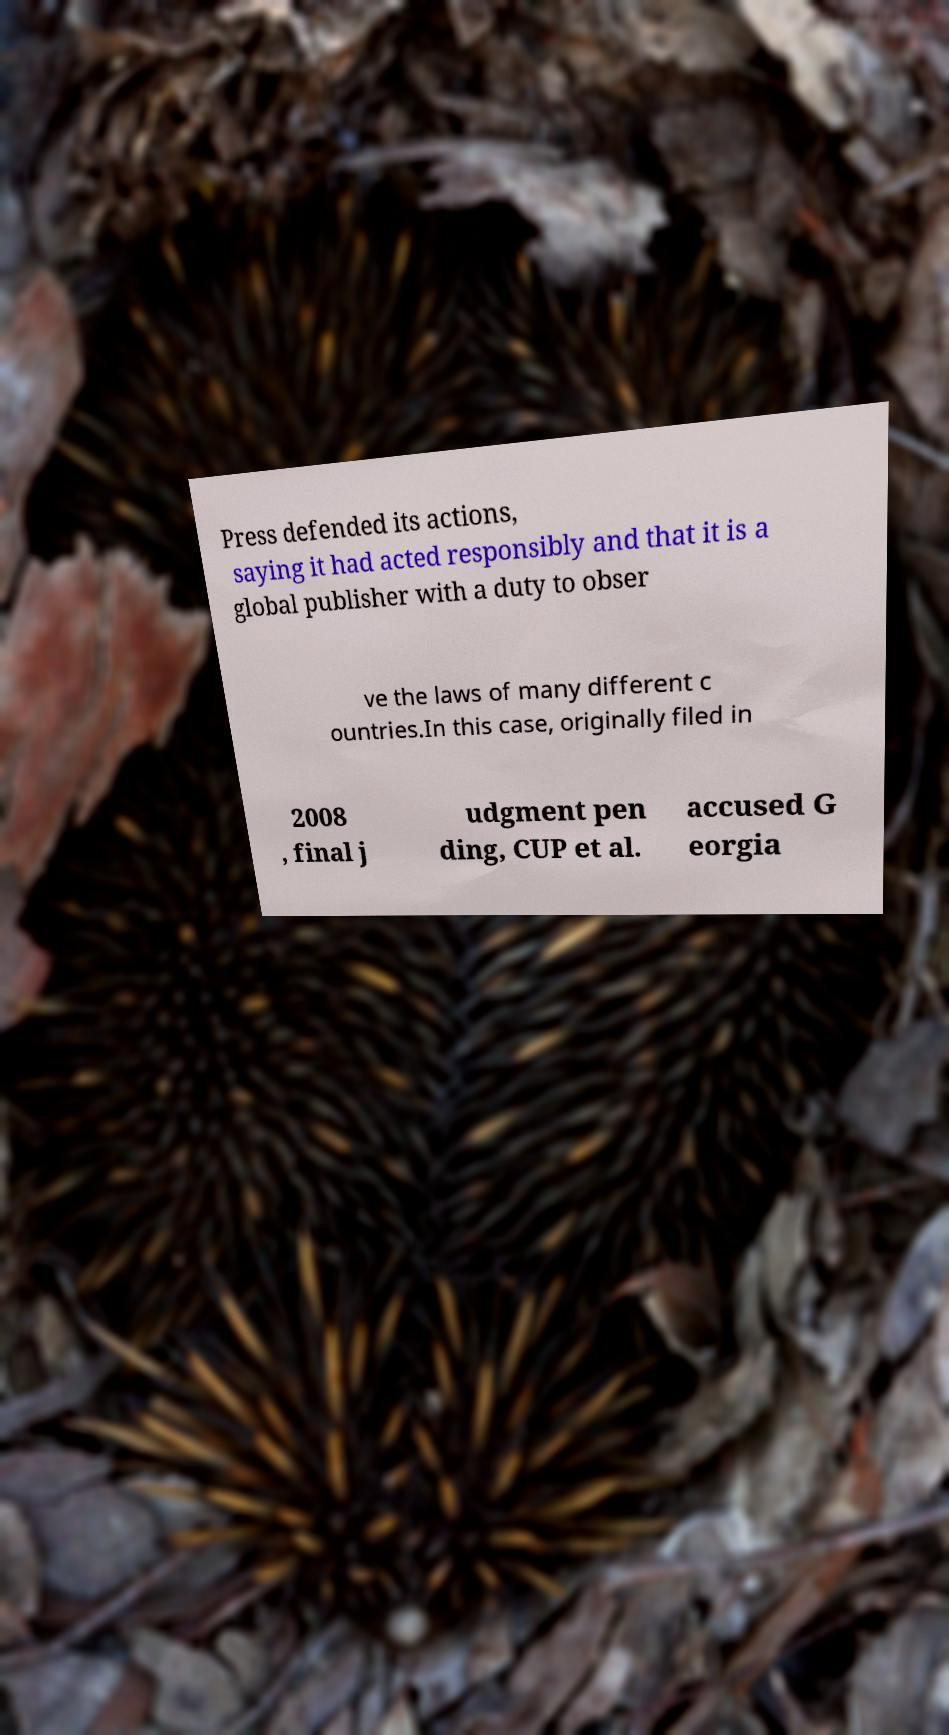There's text embedded in this image that I need extracted. Can you transcribe it verbatim? Press defended its actions, saying it had acted responsibly and that it is a global publisher with a duty to obser ve the laws of many different c ountries.In this case, originally filed in 2008 , final j udgment pen ding, CUP et al. accused G eorgia 